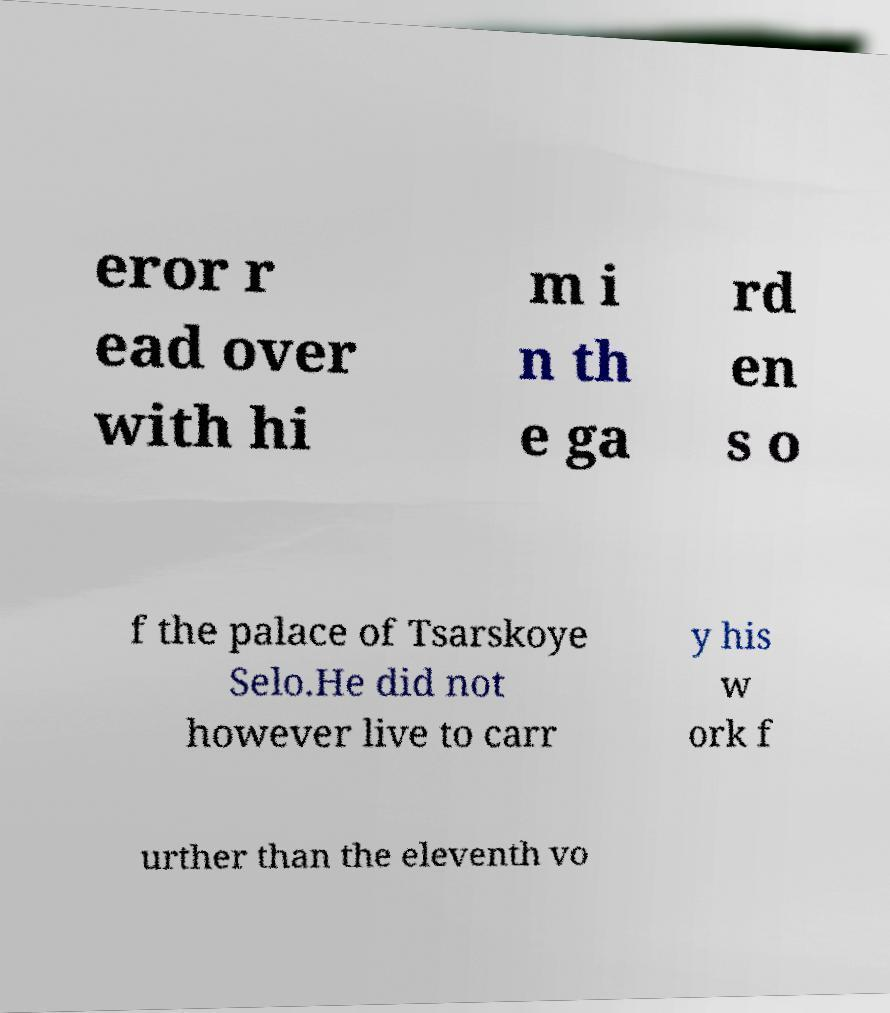Could you assist in decoding the text presented in this image and type it out clearly? eror r ead over with hi m i n th e ga rd en s o f the palace of Tsarskoye Selo.He did not however live to carr y his w ork f urther than the eleventh vo 